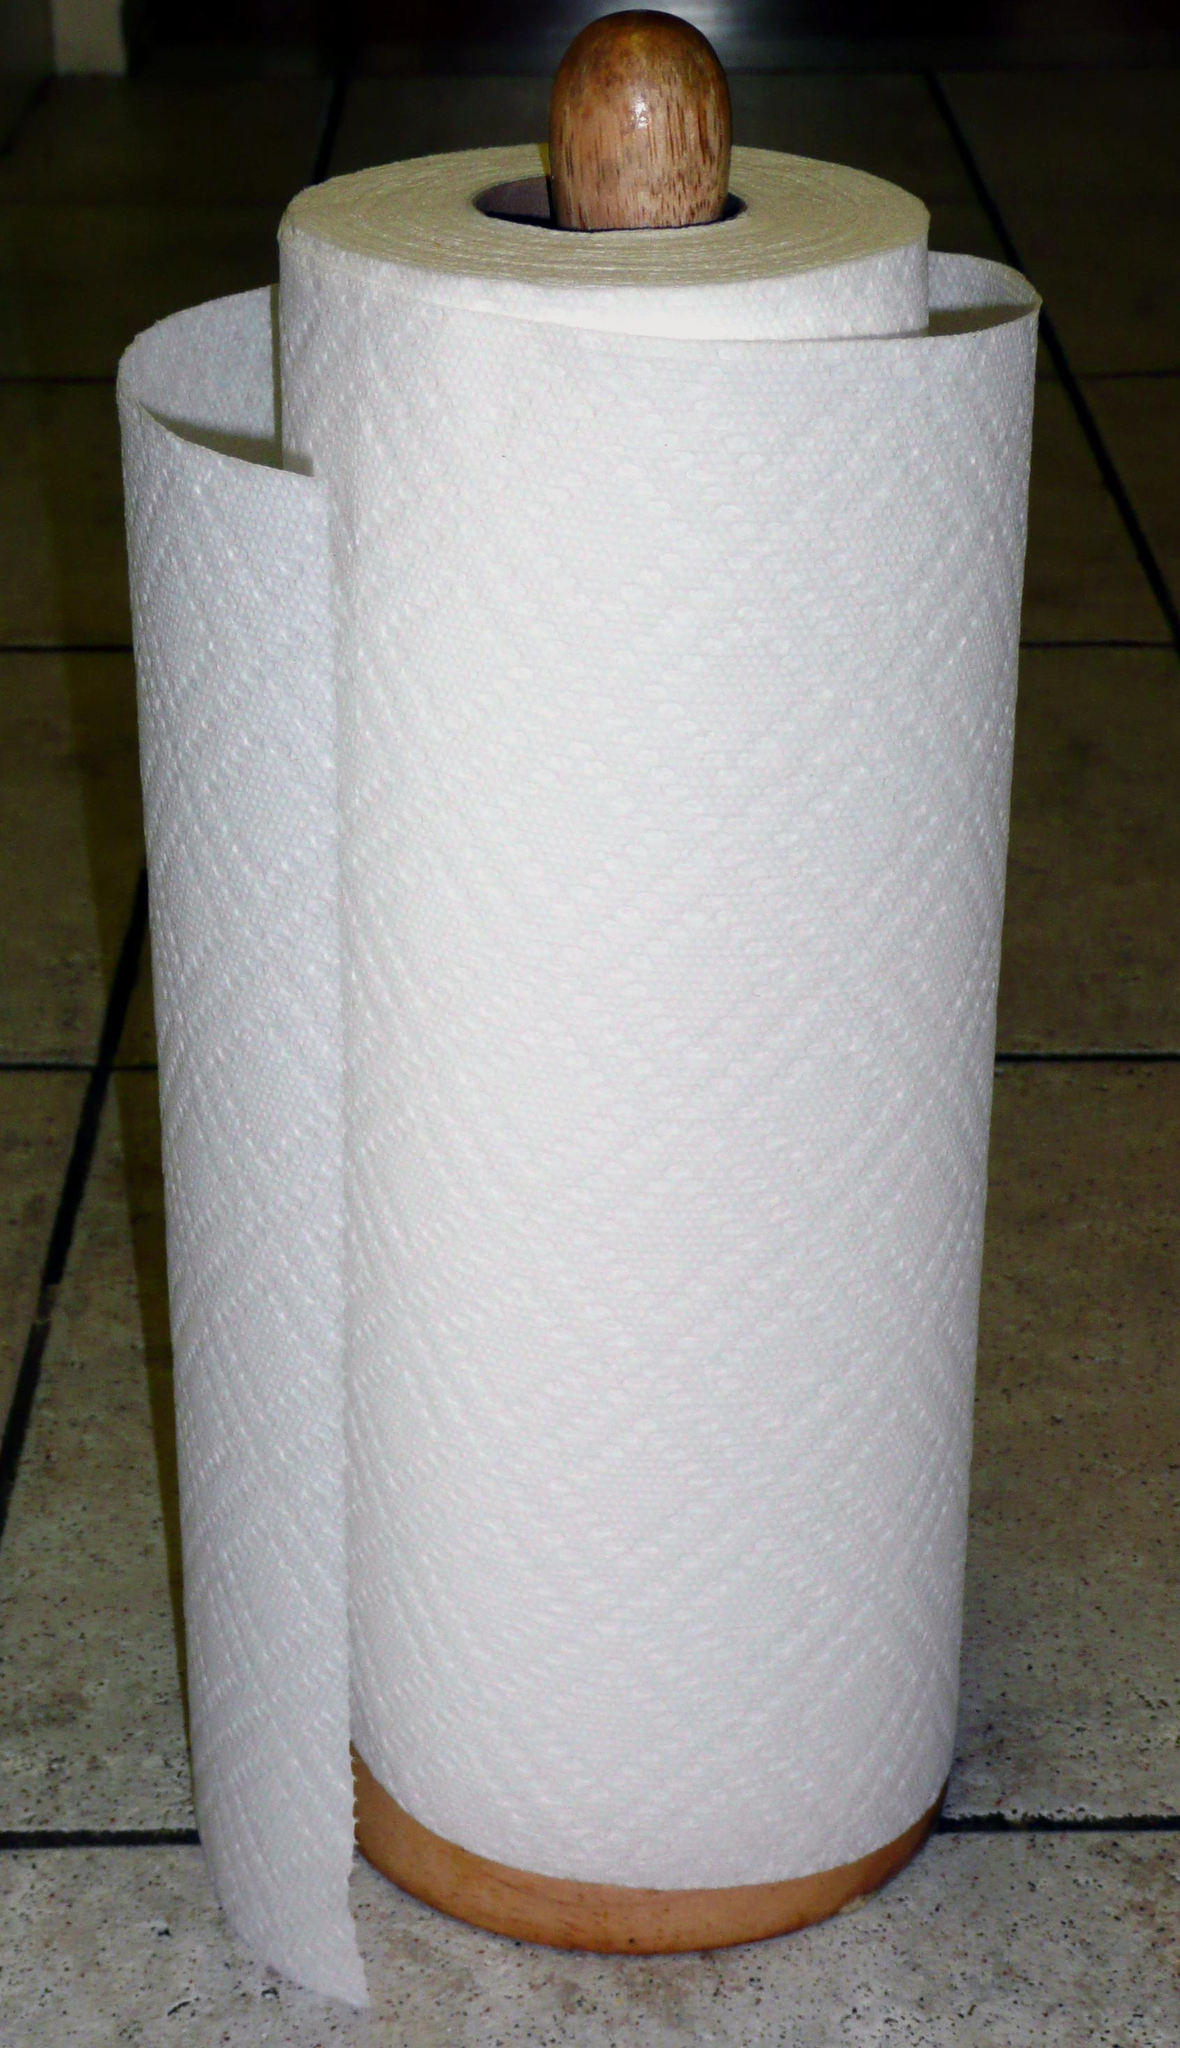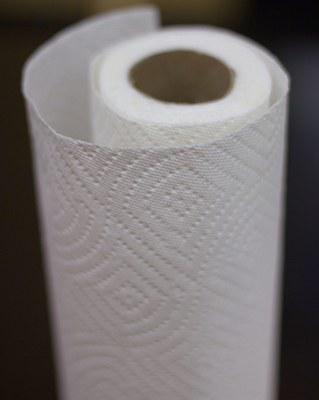The first image is the image on the left, the second image is the image on the right. Given the left and right images, does the statement "there are at least two rolls of paper towels" hold true? Answer yes or no. Yes. 